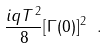Convert formula to latex. <formula><loc_0><loc_0><loc_500><loc_500>\frac { i q T ^ { 2 } } { 8 } [ \Gamma ( 0 ) ] ^ { 2 } \ .</formula> 